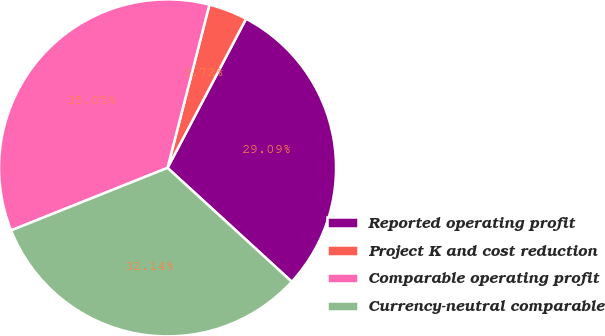Convert chart to OTSL. <chart><loc_0><loc_0><loc_500><loc_500><pie_chart><fcel>Reported operating profit<fcel>Project K and cost reduction<fcel>Comparable operating profit<fcel>Currency-neutral comparable<nl><fcel>29.09%<fcel>3.72%<fcel>35.05%<fcel>32.14%<nl></chart> 